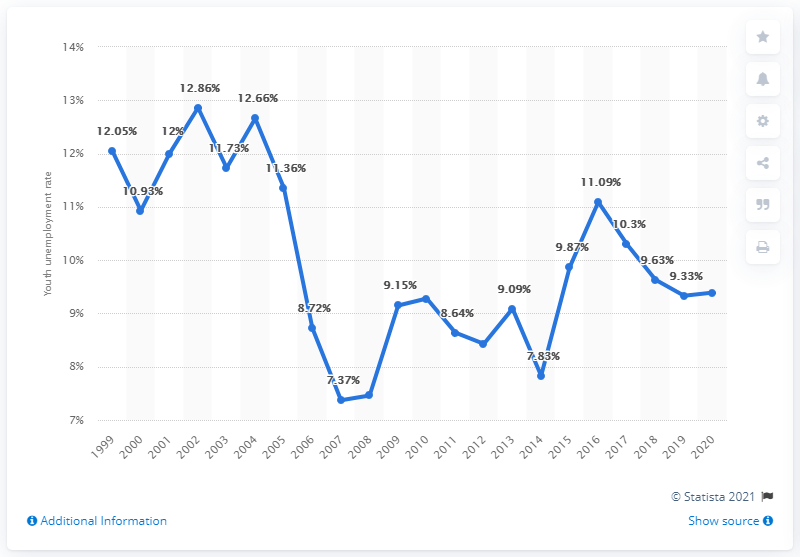What was the youth unemployment rate in Norway in 2020?
 9.39 